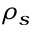<formula> <loc_0><loc_0><loc_500><loc_500>\rho _ { s }</formula> 